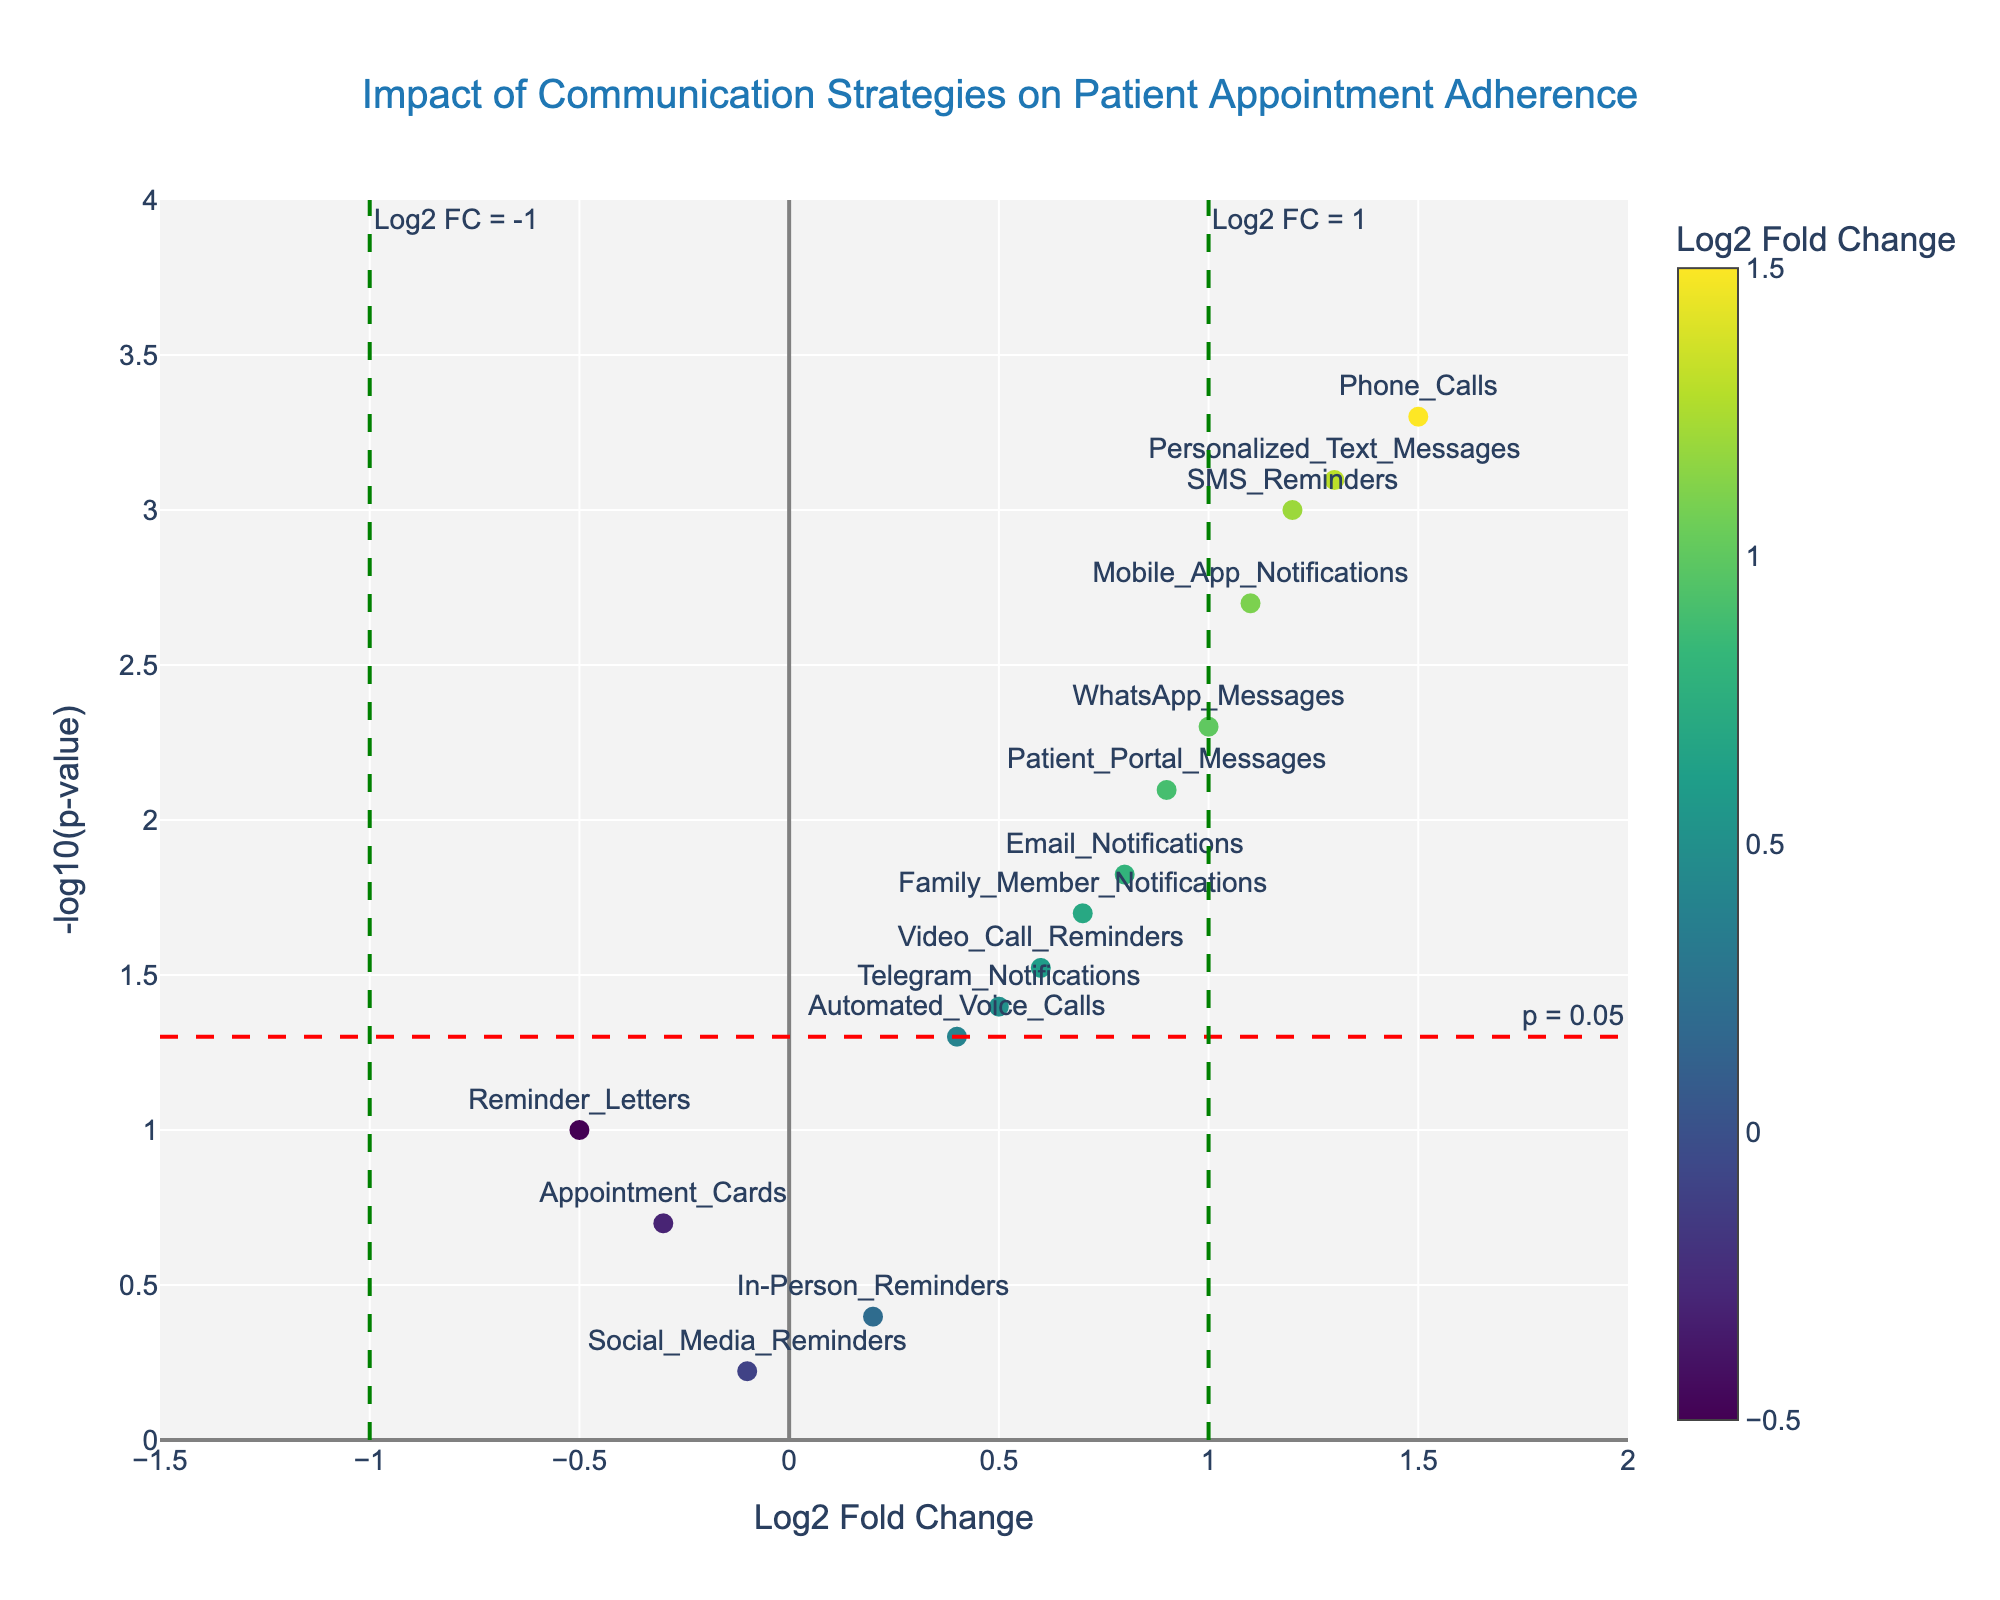Which communication strategy has the highest positive impact on patient appointment adherence? The highest positive impact corresponds to the point with the largest positive Log2 Fold Change. From the plot, this point is "Phone Calls" with a Log2 Fold Change of 1.5.
Answer: Phone Calls How many strategies have a statistically significant influence on patient appointment adherence? Statistically significant strategies are those with a p-value less than 0.05, represented by points above the line y = -log10(0.05). By counting these points on the plot, we see there are 10.
Answer: 10 Which communication strategy has a negative impact but is not statistically significant? Negative impact strategies have a negative Log2 Fold Change, and not statistically significant means the point is below the significance line for y = -log10(0.05). From the plot, "Appointment Cards" and "Reminder Letters" fit this criteria.
Answer: Appointment Cards, Reminder Letters What is the Log2 Fold Change threshold used in the plot to mark significant changes? The plot uses vertical lines at x = 1 and x = -1 as thresholds for significant Log2 Fold Change. This can be seen by the presence of dashed green lines annotated as Log2 FC = 1 and Log2 FC = -1.
Answer: 1 and -1 Are there any strategies with a Log2 Fold Change above 1 that are also statistically significant? If so, which ones? Strategies with a Log2 Fold Change above 1 are located to the right of the vertical line x = 1, and statistically significant strategies are above the line y = -log10(0.05). From the plot, "SMS Reminders", "Phone Calls", "Mobile App Notifications", "Personalized Text Messages" fit these criteria.
Answer: SMS Reminders, Phone Calls, Mobile App Notifications, Personalized Text Messages What is the Log2 Fold Change and p-value for "WhatsApp Messages"? Find the data point labeled "WhatsApp Messages" and refer to its hover information. It shows a Log2 Fold Change of 1.0 and a p-value of 0.005.
Answer: Log2 Fold Change: 1.0, P-value: 0.005 Which strategy with a positive Log2 Fold Change close to 1.0 has a p-value just under 0.05? Focus on strategies with a Log2 Fold Change near 1 and identified as significant with p-value just under 0.05. "Telegram Notifications" meet these criteria, having a Log2 Fold Change of 0.5 and p-value of 0.04.
Answer: Telegram Notifications Do any strategies not significantly influence appointment adherence despite positive Log2 Fold Change values? Positively impacting strategies have positive Log2 Fold Change values, but non-significant ones are below the line y = -log10(0.05). "Automated Voice Calls" and "In-Person Reminders" fit this category.
Answer: Automated Voice Calls, In-Person Reminders 